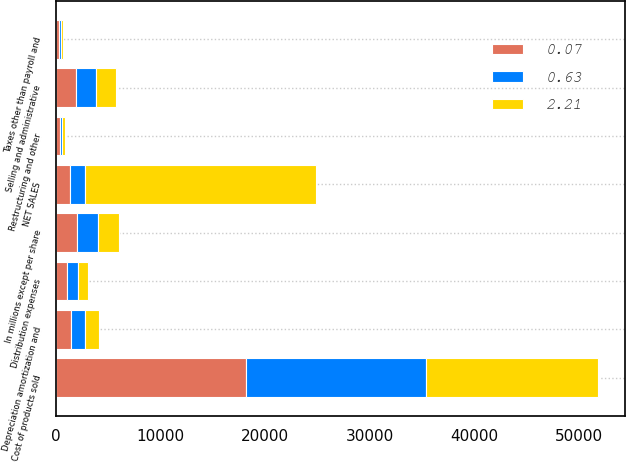<chart> <loc_0><loc_0><loc_500><loc_500><stacked_bar_chart><ecel><fcel>In millions except per share<fcel>NET SALES<fcel>Cost of products sold<fcel>Selling and administrative<fcel>Depreciation amortization and<fcel>Distribution expenses<fcel>Taxes other than payroll and<fcel>Restructuring and other<nl><fcel>0.07<fcel>2005<fcel>1366.5<fcel>18139<fcel>1876<fcel>1376<fcel>1087<fcel>233<fcel>358<nl><fcel>0.63<fcel>2004<fcel>1366.5<fcel>17225<fcel>1935<fcel>1357<fcel>1026<fcel>236<fcel>166<nl><fcel>2.21<fcel>2003<fcel>22138<fcel>16443<fcel>1888<fcel>1347<fcel>954<fcel>235<fcel>286<nl></chart> 